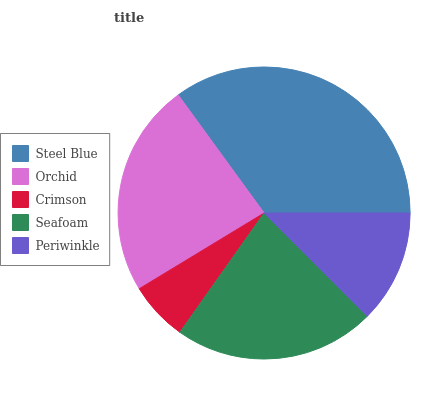Is Crimson the minimum?
Answer yes or no. Yes. Is Steel Blue the maximum?
Answer yes or no. Yes. Is Orchid the minimum?
Answer yes or no. No. Is Orchid the maximum?
Answer yes or no. No. Is Steel Blue greater than Orchid?
Answer yes or no. Yes. Is Orchid less than Steel Blue?
Answer yes or no. Yes. Is Orchid greater than Steel Blue?
Answer yes or no. No. Is Steel Blue less than Orchid?
Answer yes or no. No. Is Seafoam the high median?
Answer yes or no. Yes. Is Seafoam the low median?
Answer yes or no. Yes. Is Steel Blue the high median?
Answer yes or no. No. Is Orchid the low median?
Answer yes or no. No. 